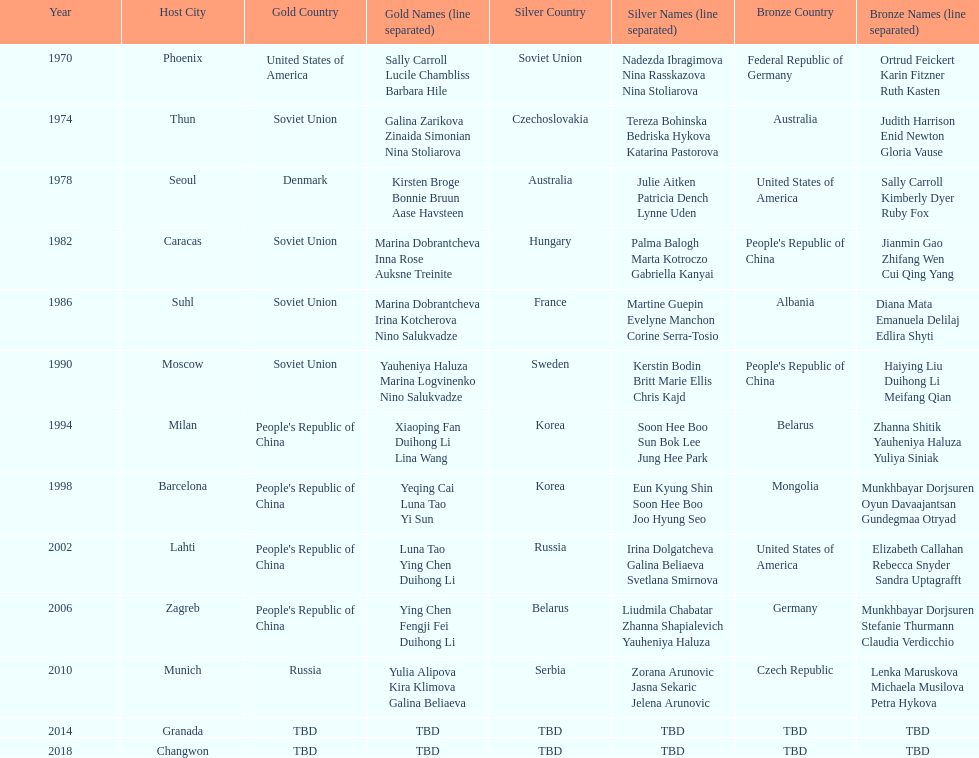How many times has germany won bronze? 2. 